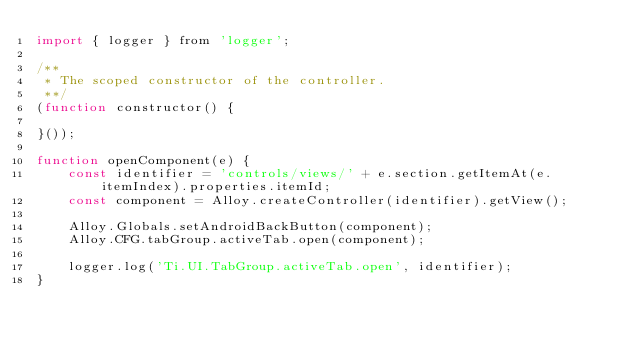Convert code to text. <code><loc_0><loc_0><loc_500><loc_500><_JavaScript_>import { logger } from 'logger';

/**
 * The scoped constructor of the controller.
 **/
(function constructor() {

}());

function openComponent(e) {
	const identifier = 'controls/views/' + e.section.getItemAt(e.itemIndex).properties.itemId;
	const component = Alloy.createController(identifier).getView();

	Alloy.Globals.setAndroidBackButton(component);
	Alloy.CFG.tabGroup.activeTab.open(component);

	logger.log('Ti.UI.TabGroup.activeTab.open', identifier);
}
</code> 